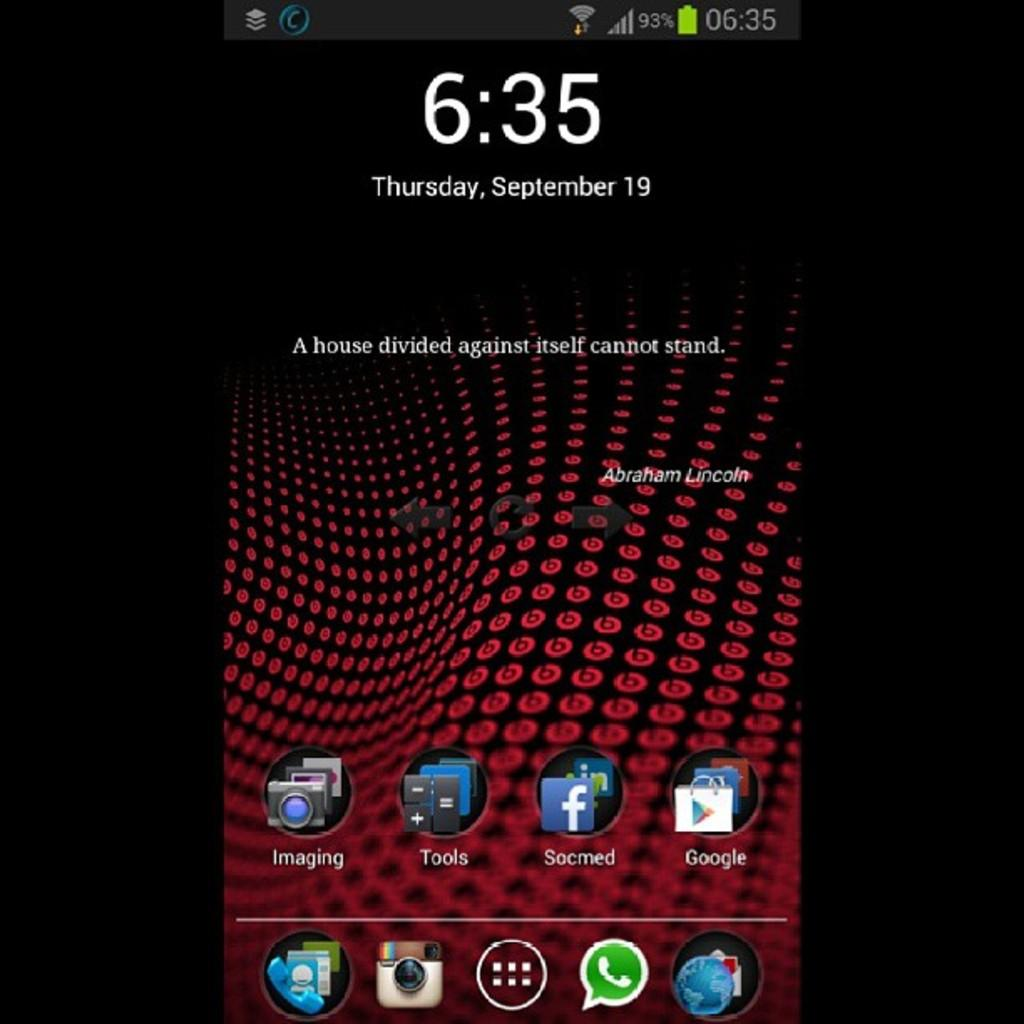Provide a one-sentence caption for the provided image. The display of a cell phone that was taken on September 19th. 